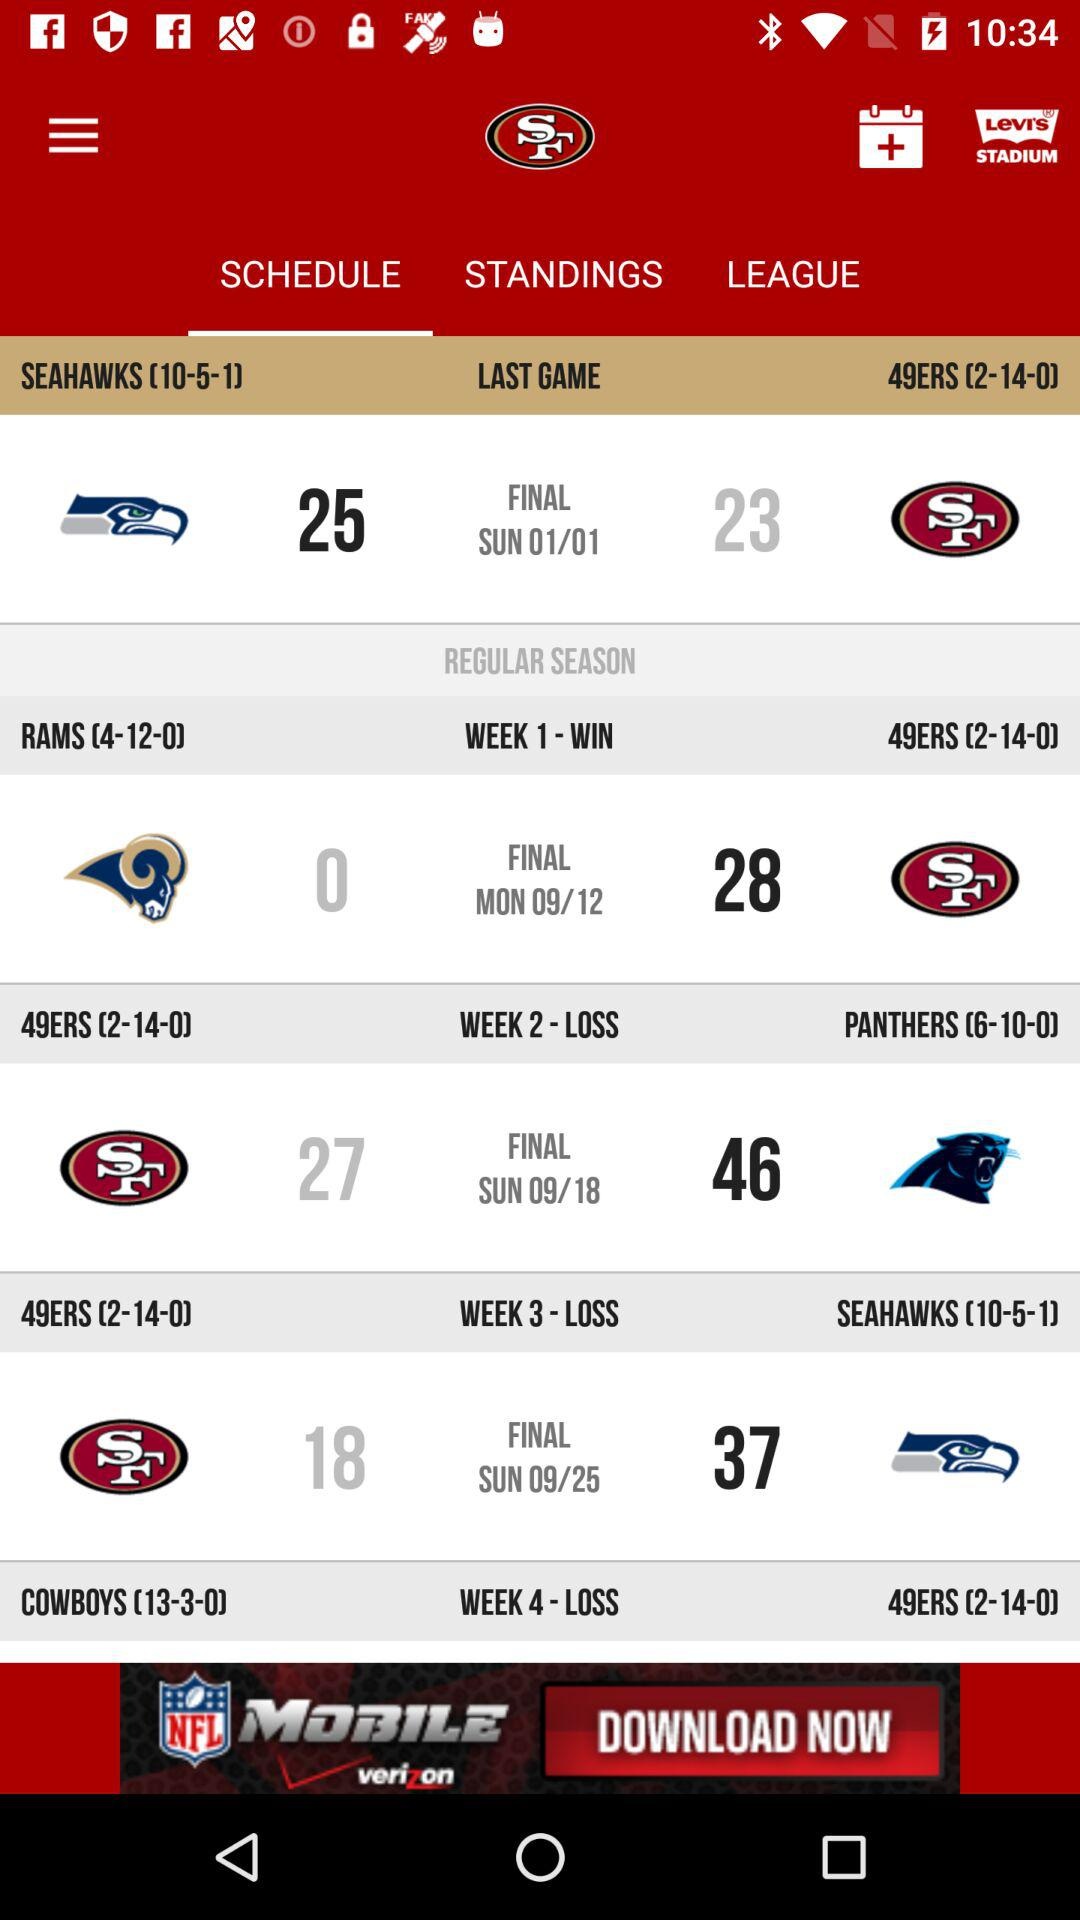What was the result of the match played in week 1? The result of the match played in week 1 was a win. 